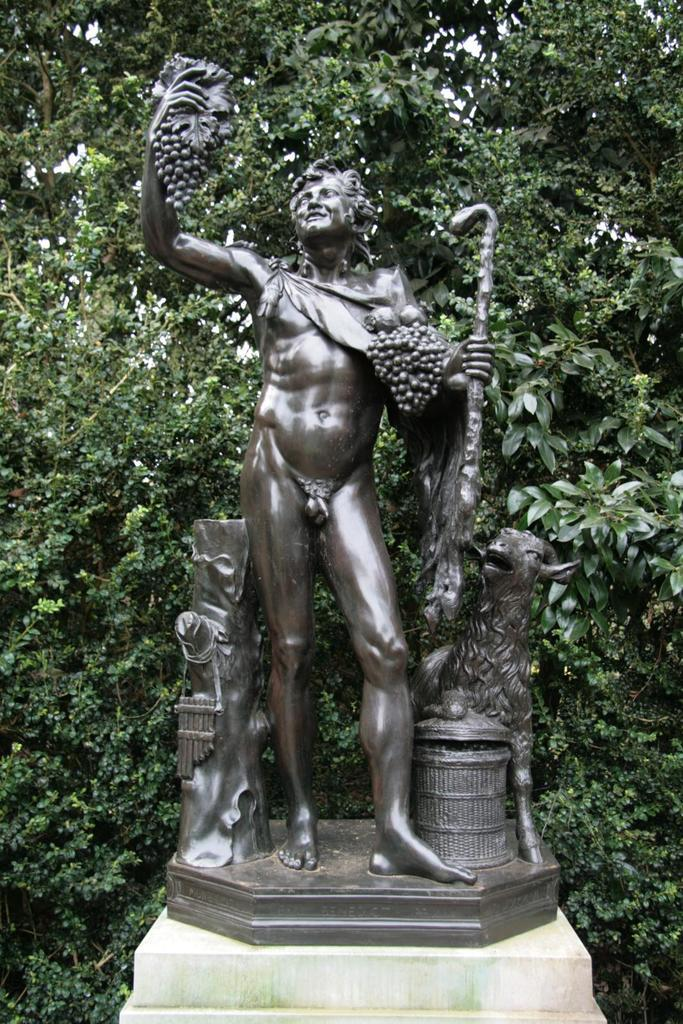What type of plant can be seen in the image? There is a tree in the image. What other object is present in the image besides the tree? There is a statue of a person in the image. How many bells are hanging from the tree in the image? There are no bells present in the image; it only features a tree and a statue of a person. What type of kite is flying near the statue in the image? There is no kite present in the image; it only features a tree and a statue of a person. 